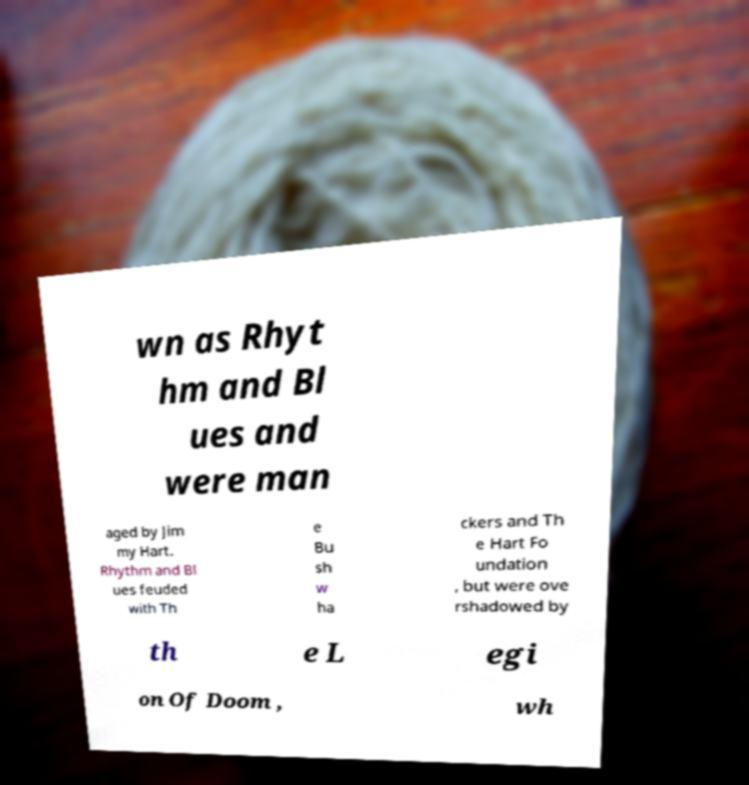Please read and relay the text visible in this image. What does it say? wn as Rhyt hm and Bl ues and were man aged by Jim my Hart. Rhythm and Bl ues feuded with Th e Bu sh w ha ckers and Th e Hart Fo undation , but were ove rshadowed by th e L egi on Of Doom , wh 